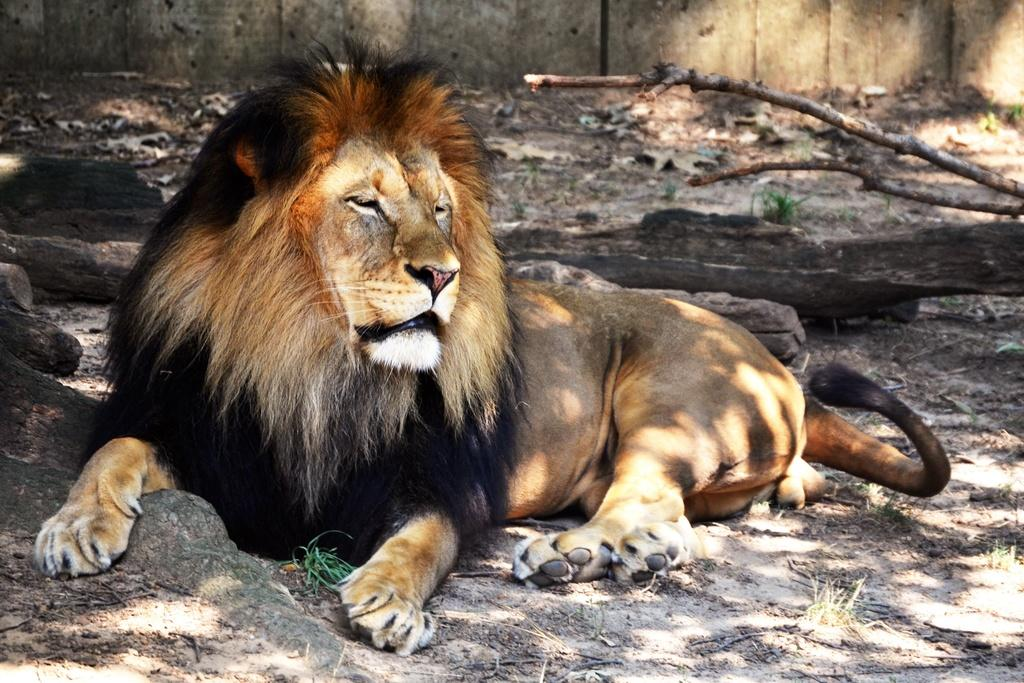What animal is the main subject of the image? There is a lion in the image. What can be seen behind the lion? Tree barks are visible behind the lion. What is in the background of the image? There is a wall in the background of the image. What type of robin can be seen perched on the carriage in the image? There is no robin or carriage present in the image; it features a lion and tree barks. 